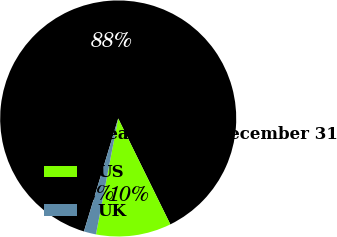Convert chart to OTSL. <chart><loc_0><loc_0><loc_500><loc_500><pie_chart><fcel>Years ended December 31<fcel>US<fcel>UK<nl><fcel>88.03%<fcel>10.3%<fcel>1.67%<nl></chart> 